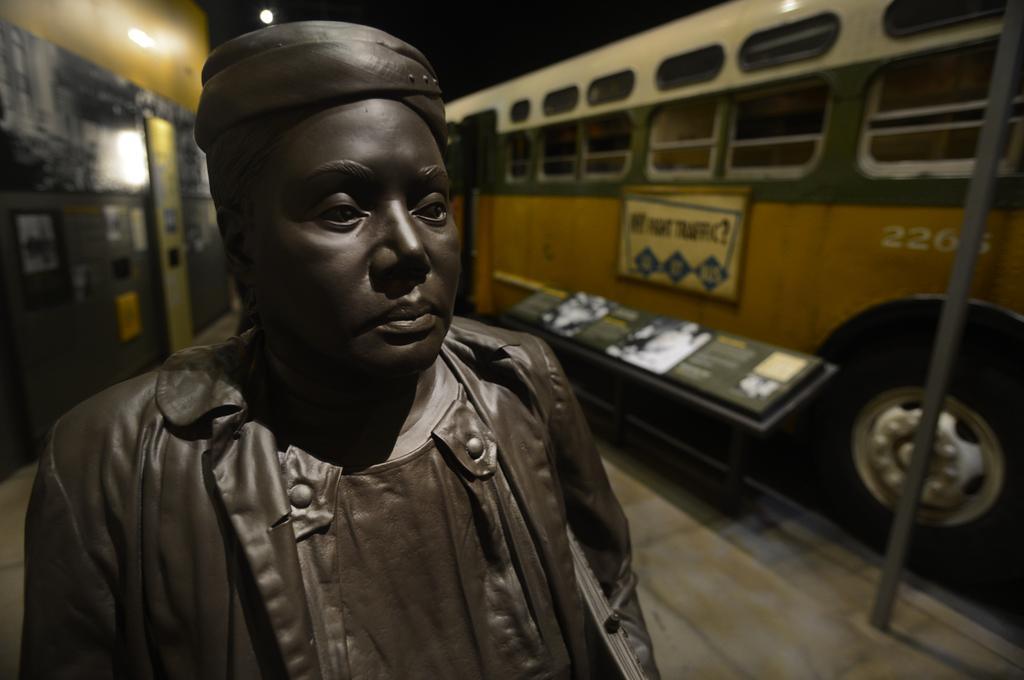Describe this image in one or two sentences. In this image we can see a statue of a woman. In the background we can see motor vehicle, pole and information boards. 